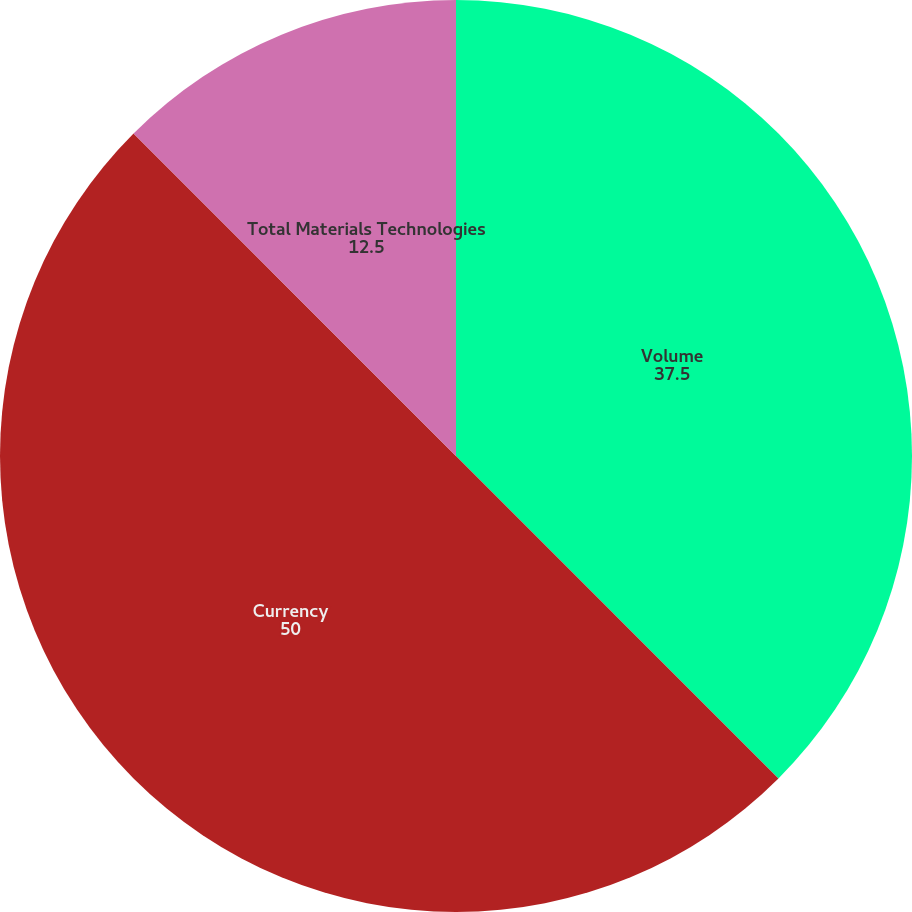Convert chart to OTSL. <chart><loc_0><loc_0><loc_500><loc_500><pie_chart><fcel>Volume<fcel>Currency<fcel>Total Materials Technologies<nl><fcel>37.5%<fcel>50.0%<fcel>12.5%<nl></chart> 